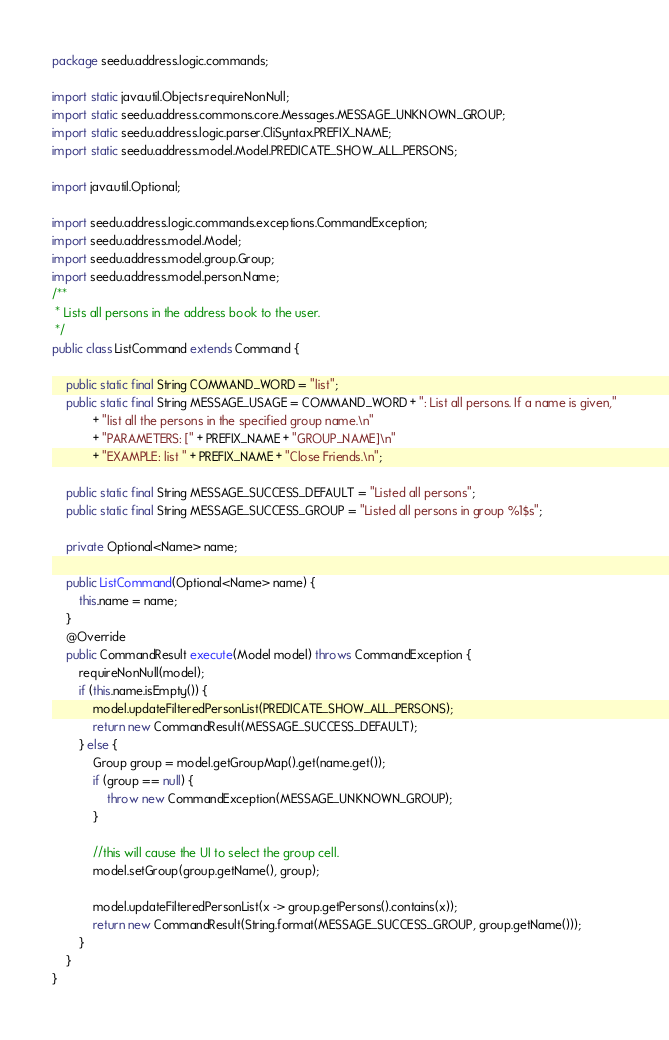Convert code to text. <code><loc_0><loc_0><loc_500><loc_500><_Java_>package seedu.address.logic.commands;

import static java.util.Objects.requireNonNull;
import static seedu.address.commons.core.Messages.MESSAGE_UNKNOWN_GROUP;
import static seedu.address.logic.parser.CliSyntax.PREFIX_NAME;
import static seedu.address.model.Model.PREDICATE_SHOW_ALL_PERSONS;

import java.util.Optional;

import seedu.address.logic.commands.exceptions.CommandException;
import seedu.address.model.Model;
import seedu.address.model.group.Group;
import seedu.address.model.person.Name;
/**
 * Lists all persons in the address book to the user.
 */
public class ListCommand extends Command {

    public static final String COMMAND_WORD = "list";
    public static final String MESSAGE_USAGE = COMMAND_WORD + ": List all persons. If a name is given,"
            + "list all the persons in the specified group name.\n"
            + "PARAMETERS: [" + PREFIX_NAME + "GROUP_NAME]\n"
            + "EXAMPLE: list " + PREFIX_NAME + "Close Friends.\n";

    public static final String MESSAGE_SUCCESS_DEFAULT = "Listed all persons";
    public static final String MESSAGE_SUCCESS_GROUP = "Listed all persons in group %1$s";

    private Optional<Name> name;

    public ListCommand(Optional<Name> name) {
        this.name = name;
    }
    @Override
    public CommandResult execute(Model model) throws CommandException {
        requireNonNull(model);
        if (this.name.isEmpty()) {
            model.updateFilteredPersonList(PREDICATE_SHOW_ALL_PERSONS);
            return new CommandResult(MESSAGE_SUCCESS_DEFAULT);
        } else {
            Group group = model.getGroupMap().get(name.get());
            if (group == null) {
                throw new CommandException(MESSAGE_UNKNOWN_GROUP);
            }

            //this will cause the UI to select the group cell.
            model.setGroup(group.getName(), group);

            model.updateFilteredPersonList(x -> group.getPersons().contains(x));
            return new CommandResult(String.format(MESSAGE_SUCCESS_GROUP, group.getName()));
        }
    }
}
</code> 